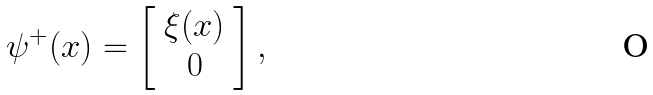<formula> <loc_0><loc_0><loc_500><loc_500>\psi ^ { + } ( x ) = \left [ \begin{array} { c c } \xi ( x ) \\ 0 \end{array} \right ] ,</formula> 